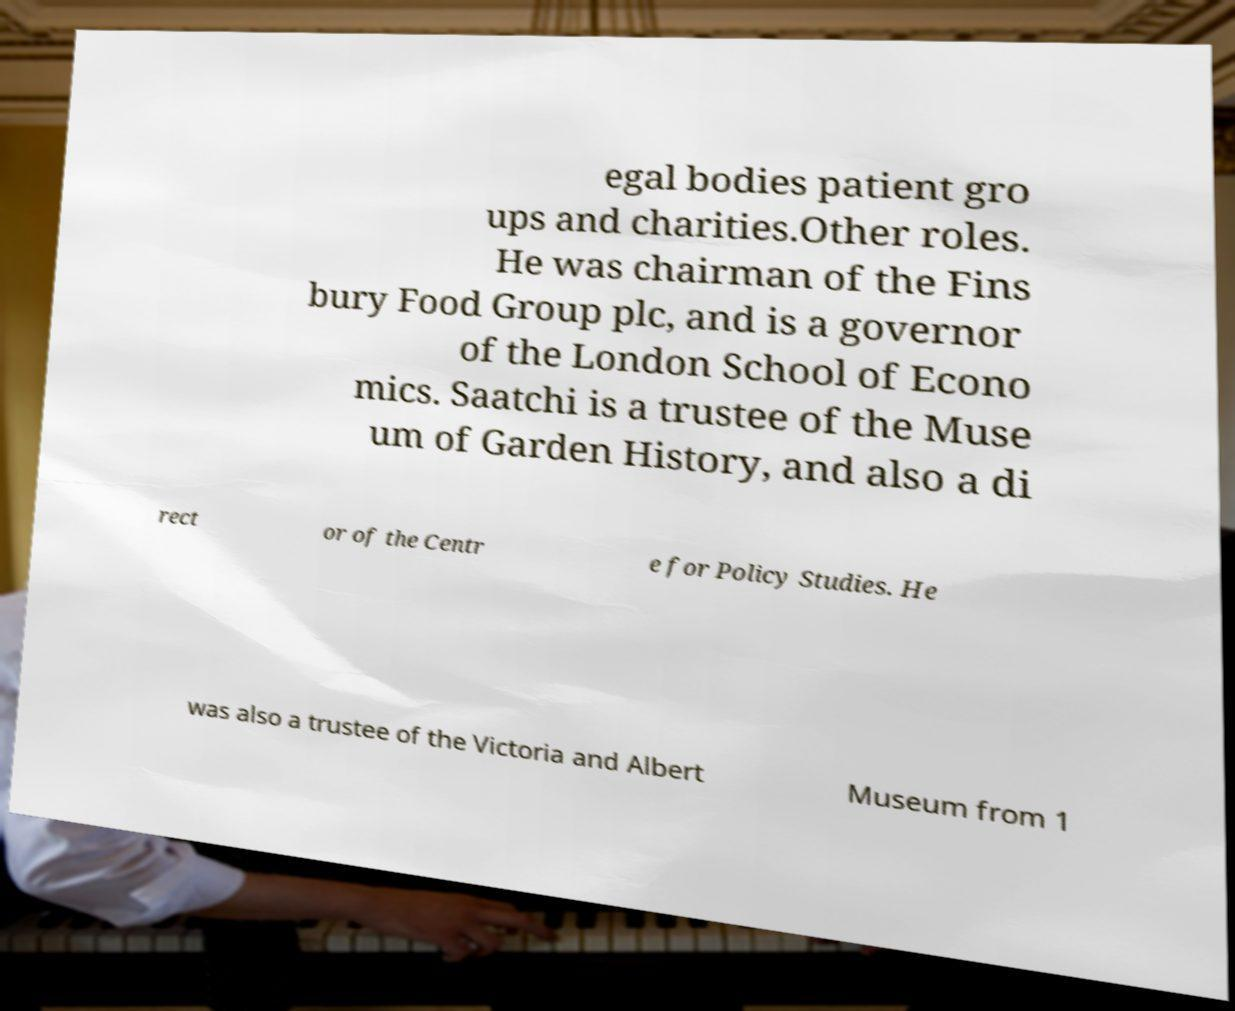Please identify and transcribe the text found in this image. egal bodies patient gro ups and charities.Other roles. He was chairman of the Fins bury Food Group plc, and is a governor of the London School of Econo mics. Saatchi is a trustee of the Muse um of Garden History, and also a di rect or of the Centr e for Policy Studies. He was also a trustee of the Victoria and Albert Museum from 1 